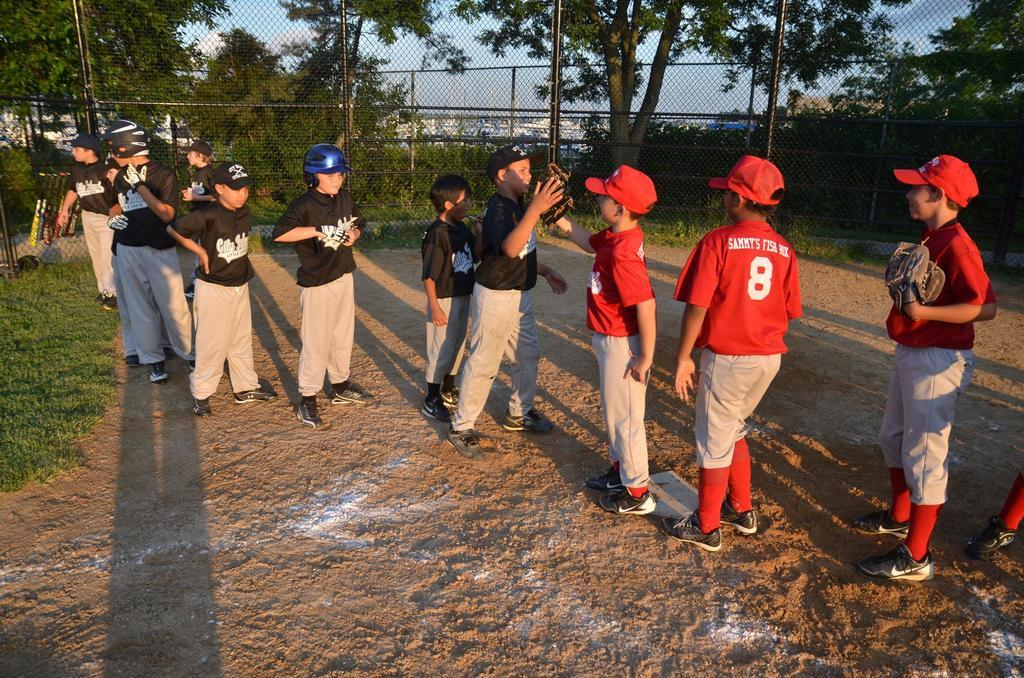<image>
Present a compact description of the photo's key features. The player who's number is eight has Sammy's on his back. 